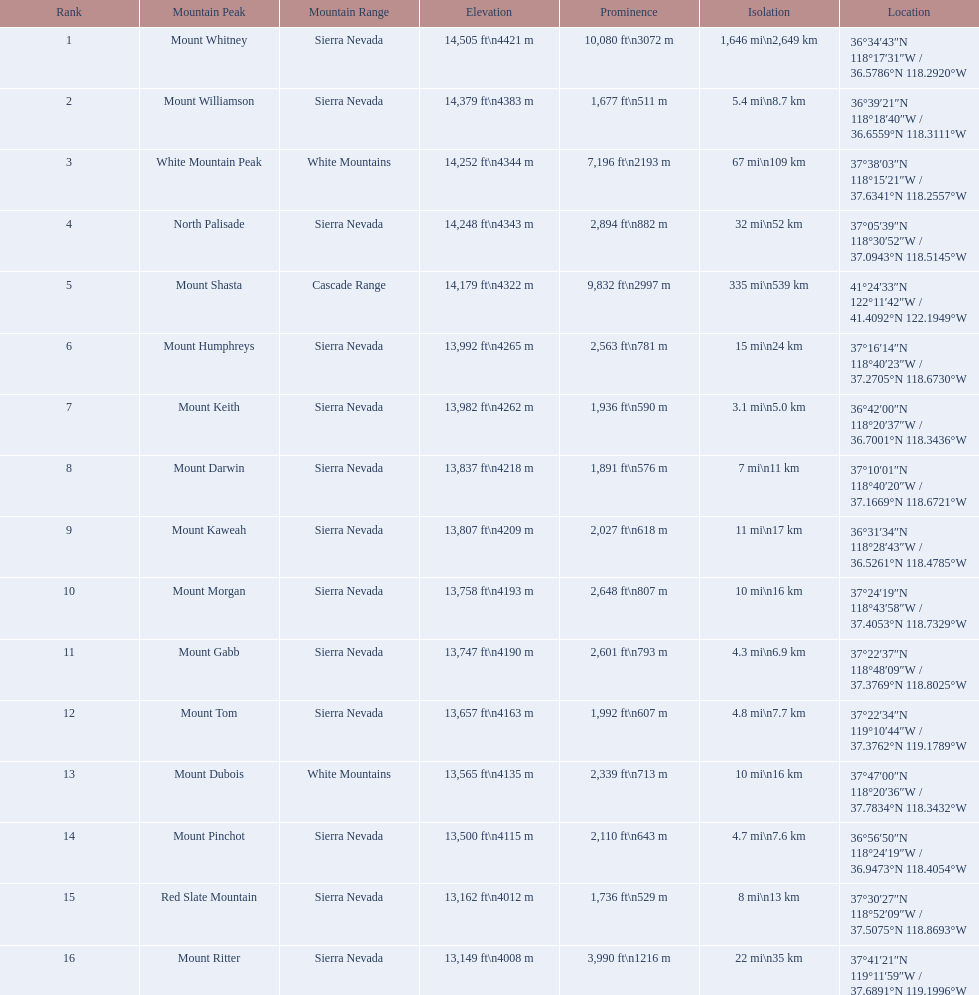What is the only mountain peak listed for the cascade range? Mount Shasta. 